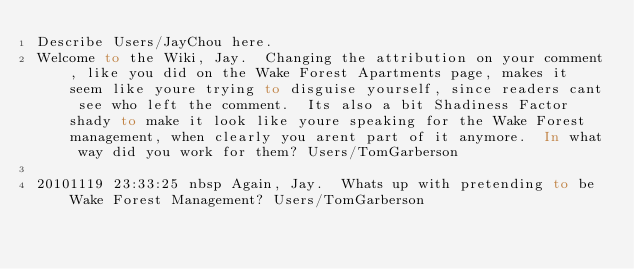Convert code to text. <code><loc_0><loc_0><loc_500><loc_500><_FORTRAN_>Describe Users/JayChou here.
Welcome to the Wiki, Jay.  Changing the attribution on your comment, like you did on the Wake Forest Apartments page, makes it seem like youre trying to disguise yourself, since readers cant see who left the comment.  Its also a bit Shadiness Factor shady to make it look like youre speaking for the Wake Forest management, when clearly you arent part of it anymore.  In what way did you work for them? Users/TomGarberson

20101119 23:33:25 nbsp Again, Jay.  Whats up with pretending to be Wake Forest Management? Users/TomGarberson
</code> 